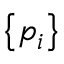<formula> <loc_0><loc_0><loc_500><loc_500>\left \{ p _ { i } \right \}</formula> 